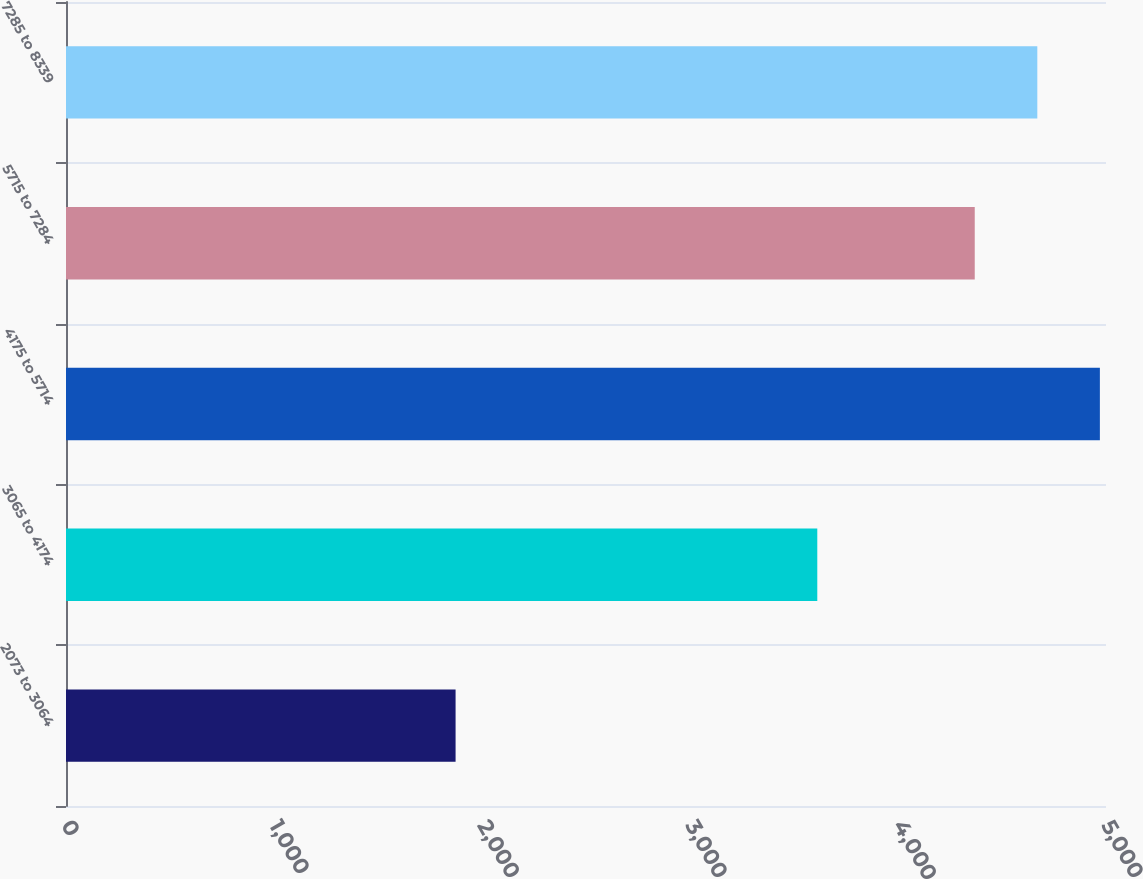<chart> <loc_0><loc_0><loc_500><loc_500><bar_chart><fcel>2073 to 3064<fcel>3065 to 4174<fcel>4175 to 5714<fcel>5715 to 7284<fcel>7285 to 8339<nl><fcel>1873<fcel>3612<fcel>4970.6<fcel>4369<fcel>4669.8<nl></chart> 